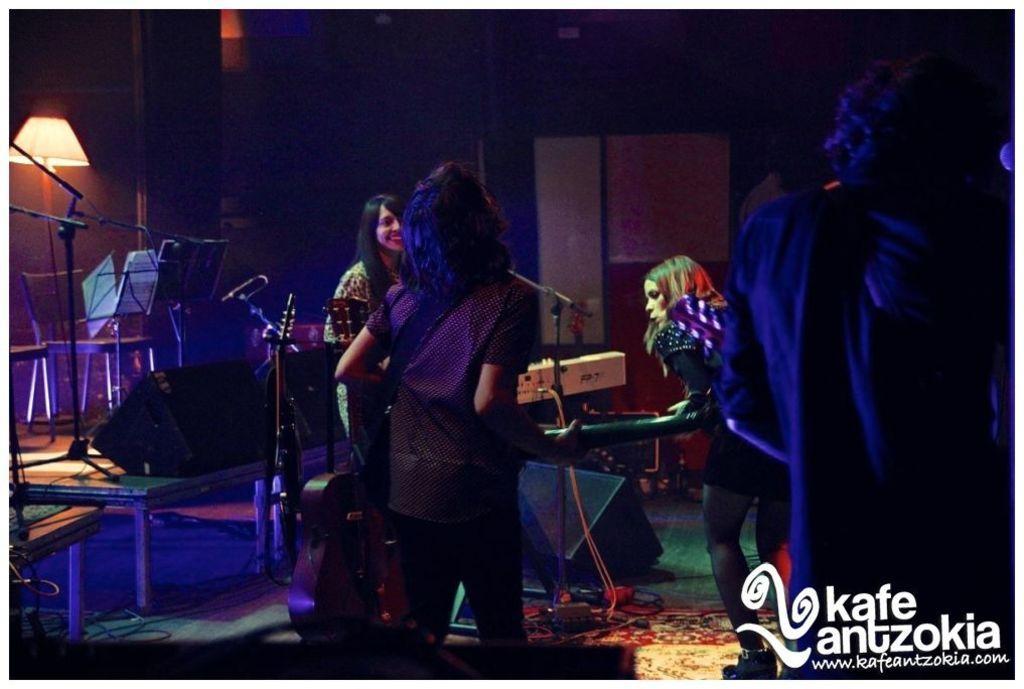Can you describe this image briefly? In this image I can see few people standing and wearing the different color dresses. I can see few people are holding the musical instruments. To the left I can see the mics, chairs and the lamp. 